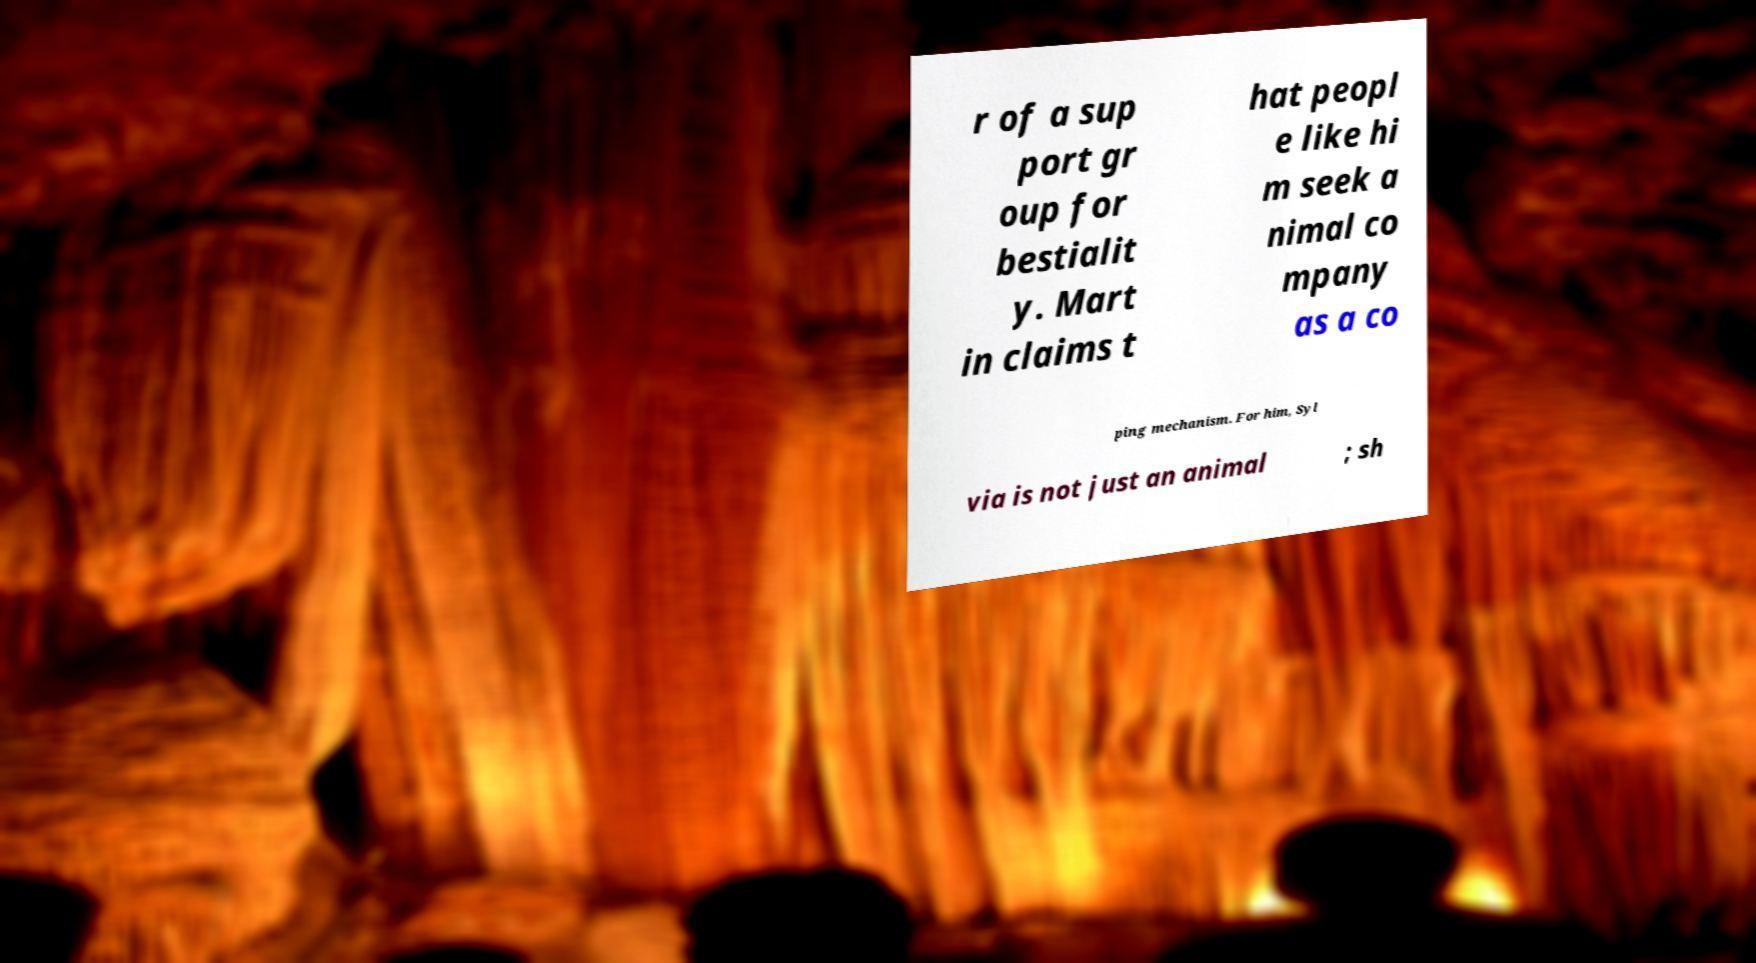There's text embedded in this image that I need extracted. Can you transcribe it verbatim? r of a sup port gr oup for bestialit y. Mart in claims t hat peopl e like hi m seek a nimal co mpany as a co ping mechanism. For him, Syl via is not just an animal ; sh 